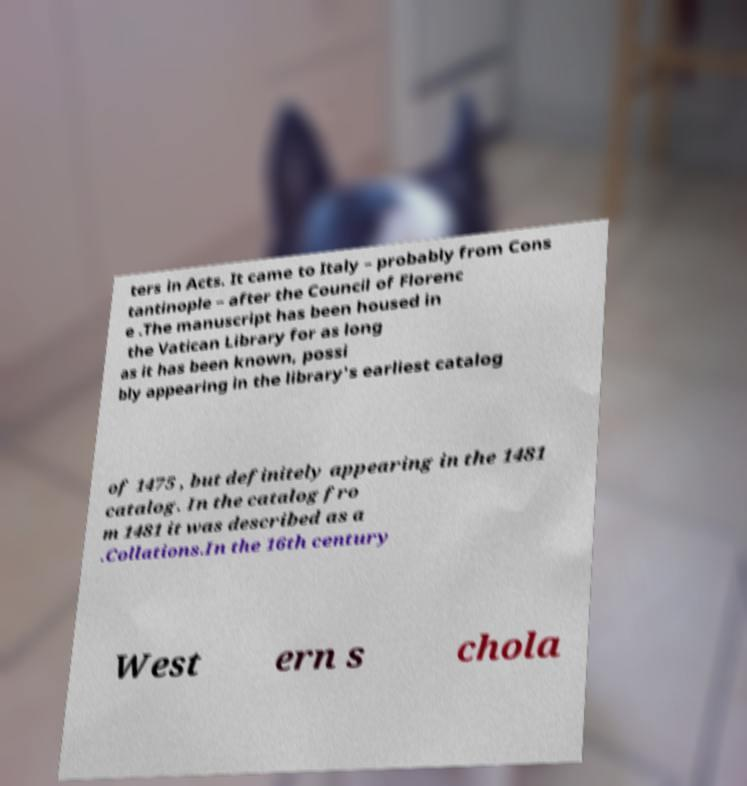Please read and relay the text visible in this image. What does it say? ters in Acts. It came to Italy – probably from Cons tantinople – after the Council of Florenc e .The manuscript has been housed in the Vatican Library for as long as it has been known, possi bly appearing in the library's earliest catalog of 1475 , but definitely appearing in the 1481 catalog. In the catalog fro m 1481 it was described as a .Collations.In the 16th century West ern s chola 